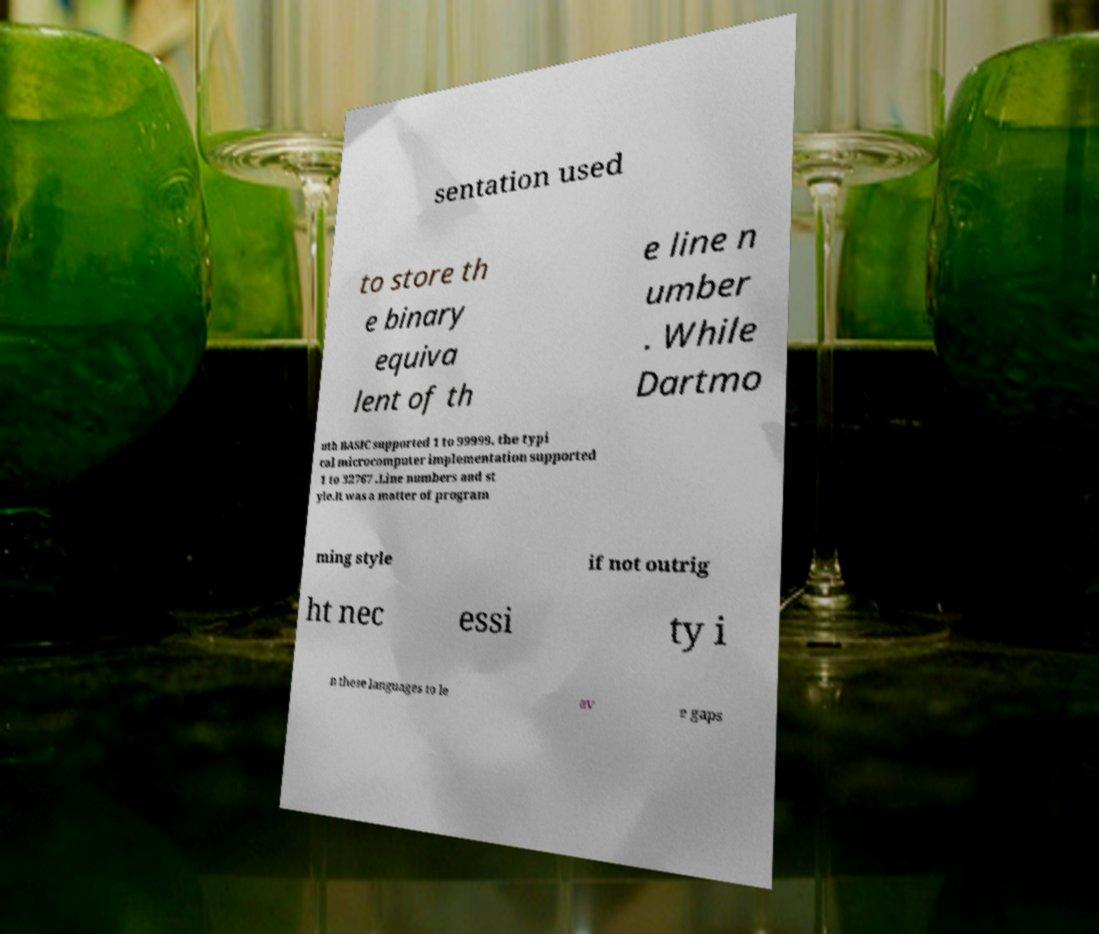Please identify and transcribe the text found in this image. sentation used to store th e binary equiva lent of th e line n umber . While Dartmo uth BASIC supported 1 to 99999, the typi cal microcomputer implementation supported 1 to 32767 .Line numbers and st yle.It was a matter of program ming style if not outrig ht nec essi ty i n these languages to le av e gaps 